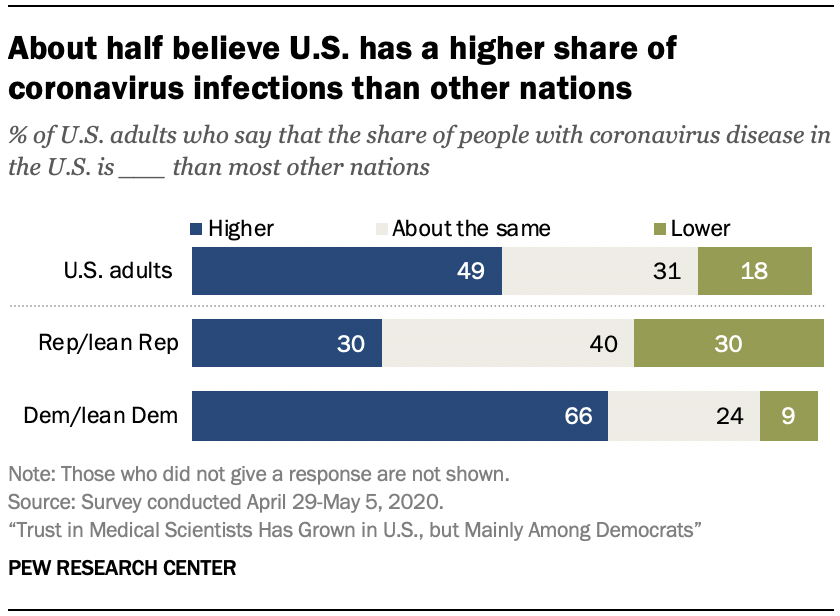Point out several critical features in this image. According to a survey conducted among US adults, 49% believe that the share of people with coronavirus disease in the US is higher than in other nations. According to a survey of US adults, 98% believe that the share of people with coronavirus disease in the US is either higher, about the same, or lower compared to what is reported by the government. 